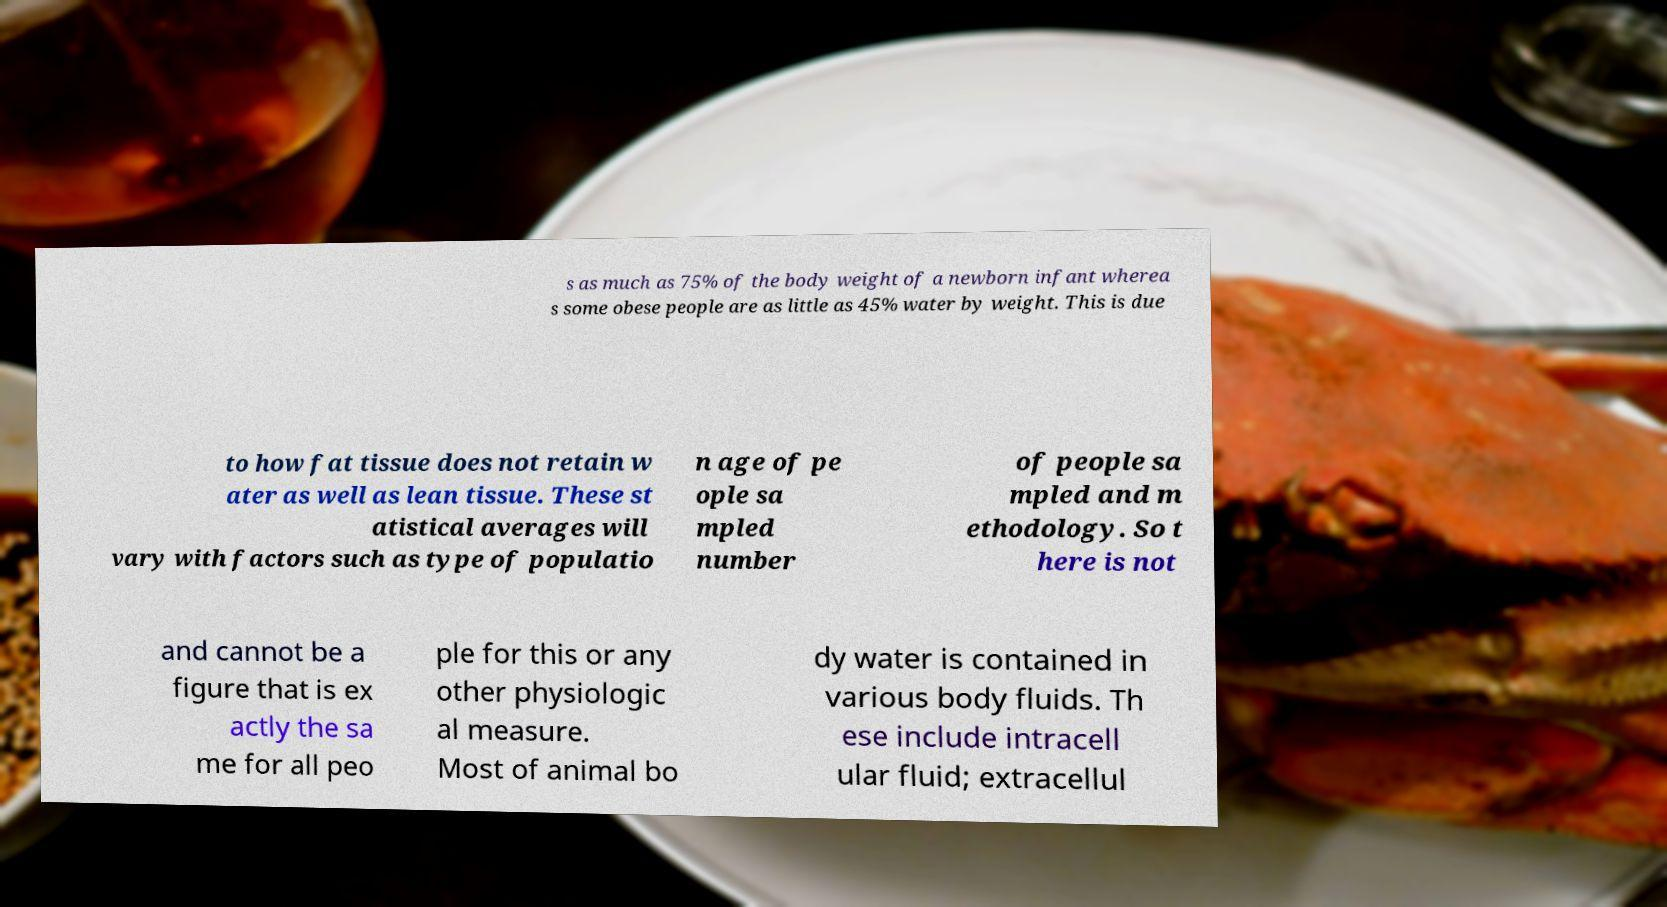Can you read and provide the text displayed in the image?This photo seems to have some interesting text. Can you extract and type it out for me? s as much as 75% of the body weight of a newborn infant wherea s some obese people are as little as 45% water by weight. This is due to how fat tissue does not retain w ater as well as lean tissue. These st atistical averages will vary with factors such as type of populatio n age of pe ople sa mpled number of people sa mpled and m ethodology. So t here is not and cannot be a figure that is ex actly the sa me for all peo ple for this or any other physiologic al measure. Most of animal bo dy water is contained in various body fluids. Th ese include intracell ular fluid; extracellul 